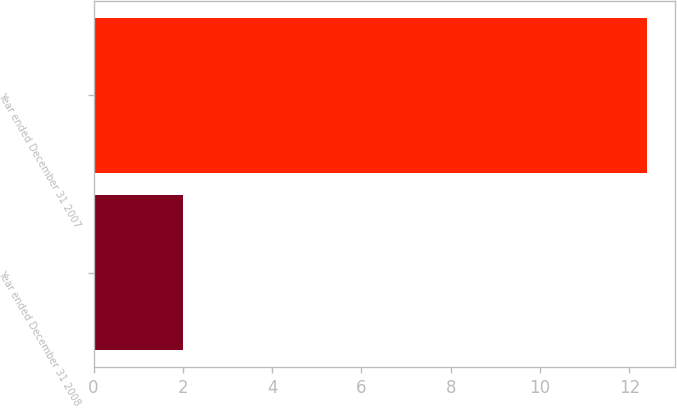Convert chart to OTSL. <chart><loc_0><loc_0><loc_500><loc_500><bar_chart><fcel>Year ended December 31 2008<fcel>Year ended December 31 2007<nl><fcel>2<fcel>12.4<nl></chart> 